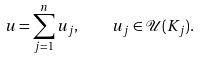Convert formula to latex. <formula><loc_0><loc_0><loc_500><loc_500>u = \sum _ { j = 1 } ^ { n } u _ { j } , \quad u _ { j } \in \mathcal { U } ( K _ { j } ) .</formula> 